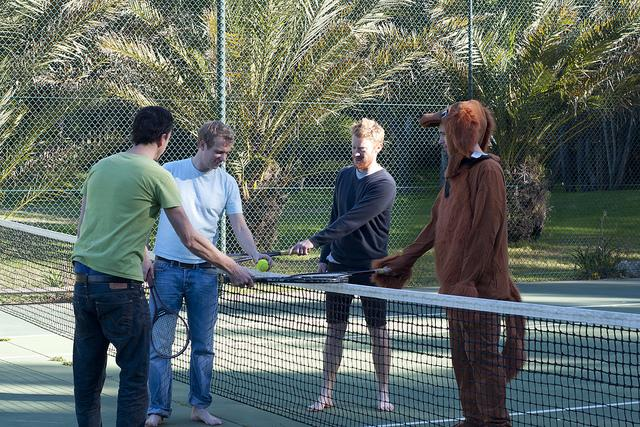Which one is inappropriately dressed? Please explain your reasoning. brown outfit. The person in the brown outfit isn't wearing athletic clothes. 